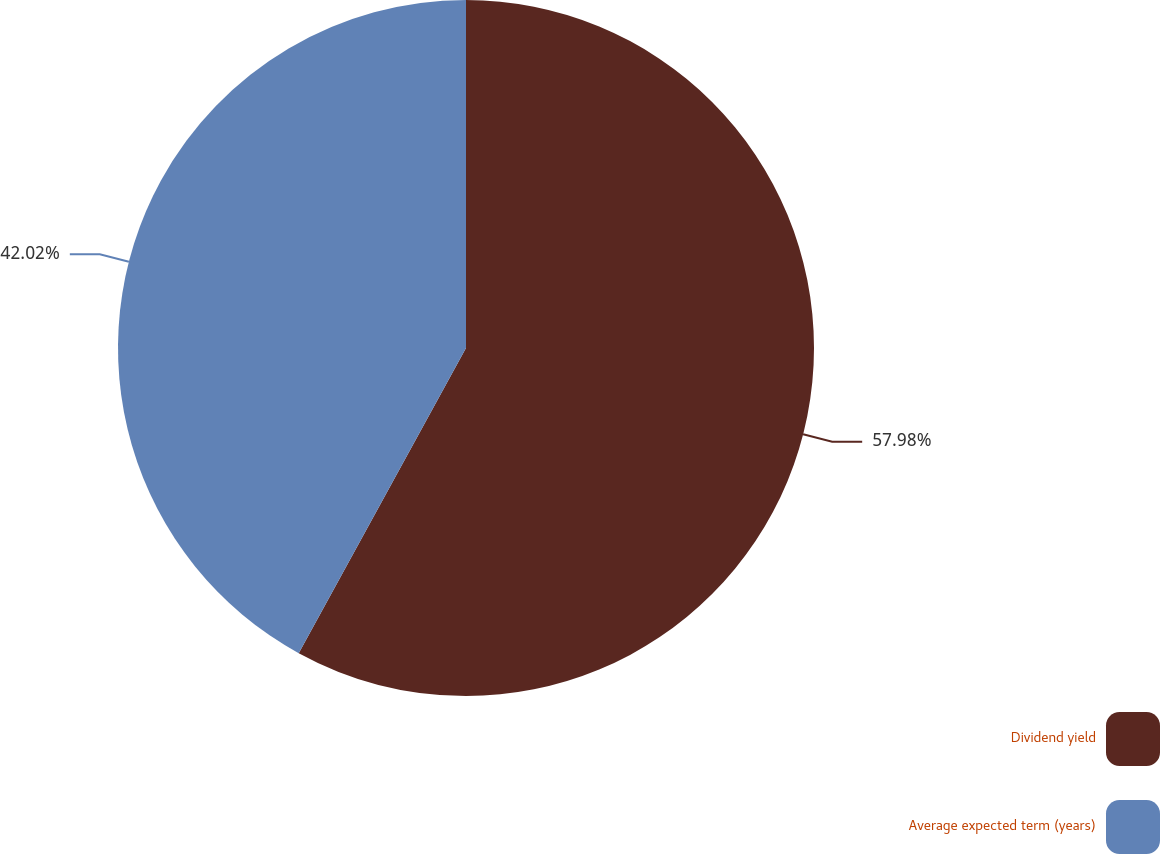Convert chart. <chart><loc_0><loc_0><loc_500><loc_500><pie_chart><fcel>Dividend yield<fcel>Average expected term (years)<nl><fcel>57.98%<fcel>42.02%<nl></chart> 